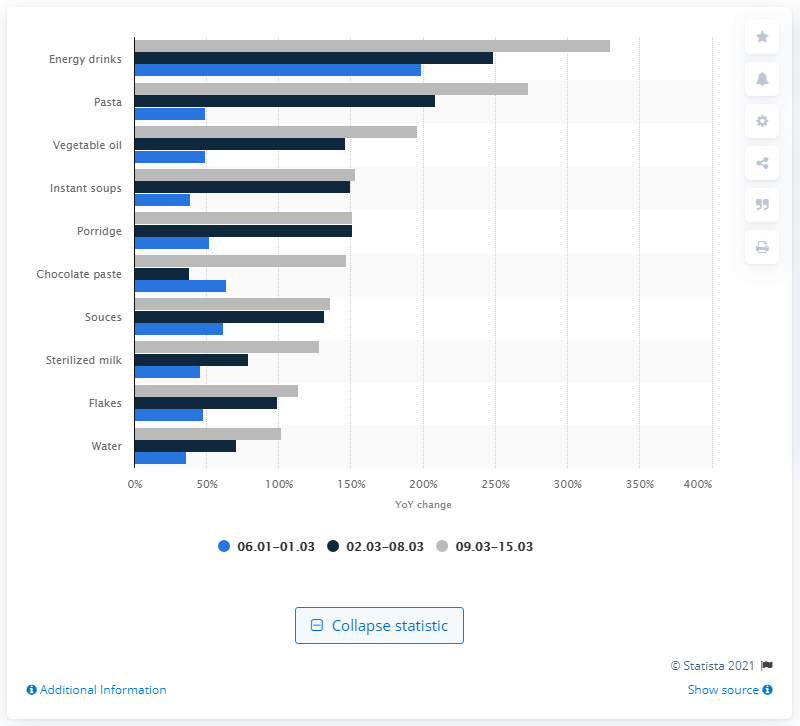Highlight a few significant elements in this photo. The most commonly purchased item during the COVID-19 pandemic in Russia was energy drinks. 